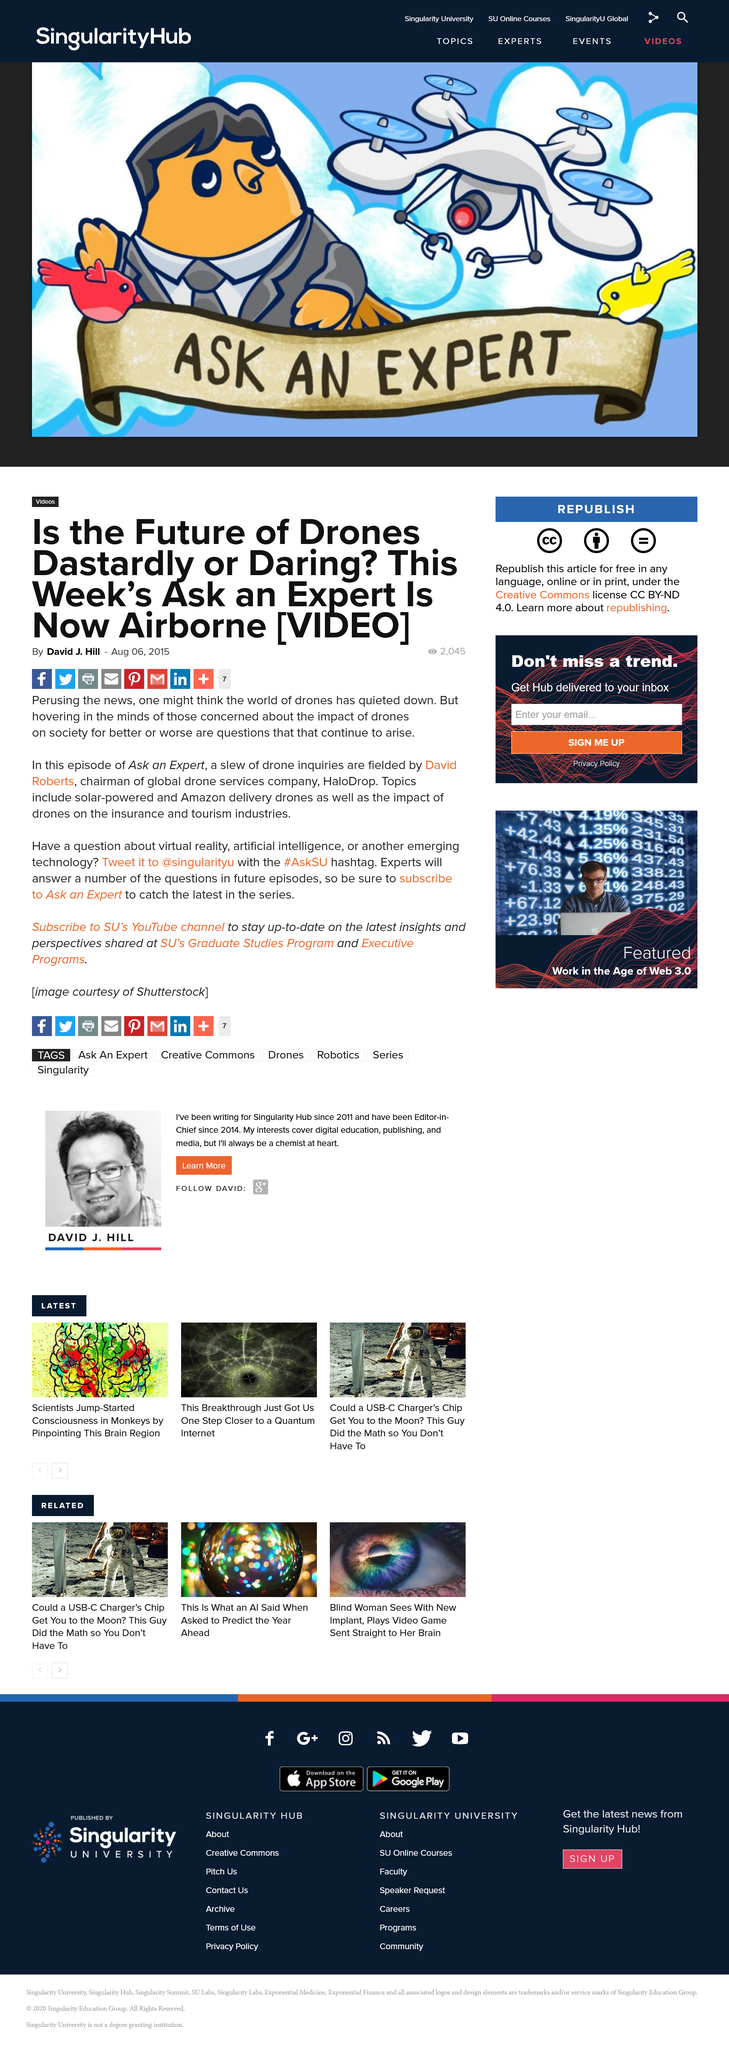Identify some key points in this picture. To stay informed about the impact of drones, one can watch an episode of "Ask An Expert" featuring David Roberts or tweet @singularityu with the #AskSU hashtag. You should subscribe to SU's YouTube channel in order to stay informed on the latest insights and perspectives. David Roberts is the chairman of HaloDrop. 